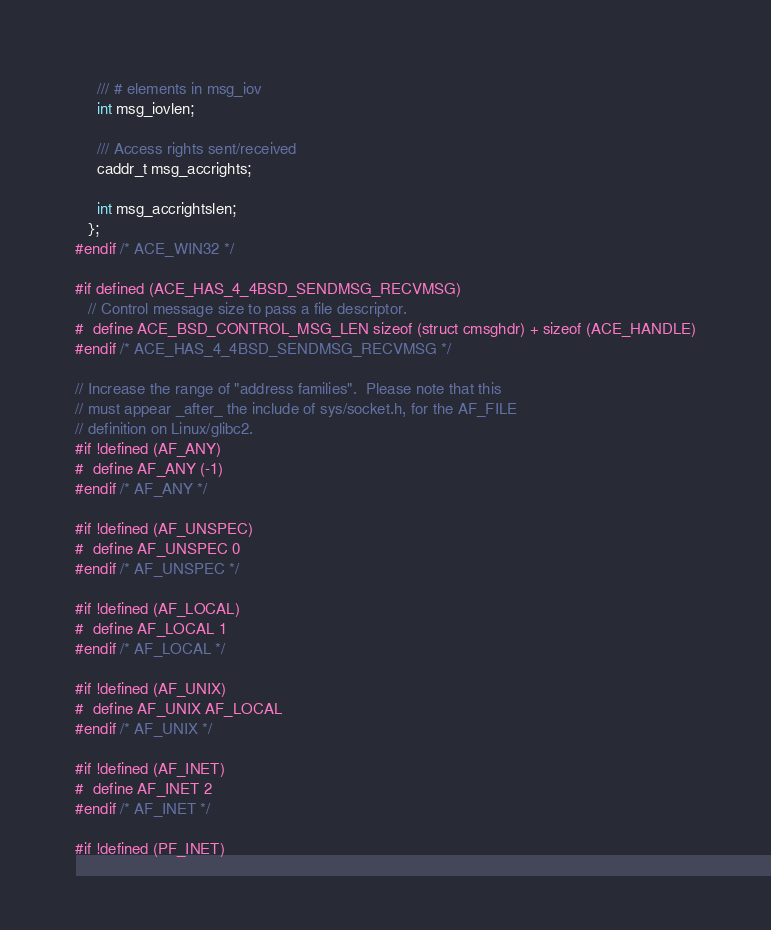<code> <loc_0><loc_0><loc_500><loc_500><_C_>     /// # elements in msg_iov
     int msg_iovlen;

     /// Access rights sent/received
     caddr_t msg_accrights;

     int msg_accrightslen;
   };
#endif /* ACE_WIN32 */

#if defined (ACE_HAS_4_4BSD_SENDMSG_RECVMSG)
   // Control message size to pass a file descriptor.
#  define ACE_BSD_CONTROL_MSG_LEN sizeof (struct cmsghdr) + sizeof (ACE_HANDLE)
#endif /* ACE_HAS_4_4BSD_SENDMSG_RECVMSG */

// Increase the range of "address families".  Please note that this
// must appear _after_ the include of sys/socket.h, for the AF_FILE
// definition on Linux/glibc2.
#if !defined (AF_ANY)
#  define AF_ANY (-1)
#endif /* AF_ANY */

#if !defined (AF_UNSPEC)
#  define AF_UNSPEC 0
#endif /* AF_UNSPEC */

#if !defined (AF_LOCAL)
#  define AF_LOCAL 1
#endif /* AF_LOCAL */

#if !defined (AF_UNIX)
#  define AF_UNIX AF_LOCAL
#endif /* AF_UNIX */

#if !defined (AF_INET)
#  define AF_INET 2
#endif /* AF_INET */

#if !defined (PF_INET)</code> 